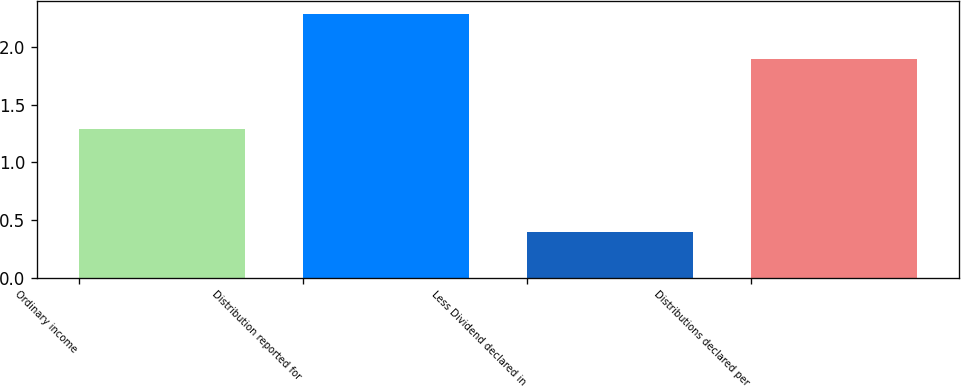Convert chart. <chart><loc_0><loc_0><loc_500><loc_500><bar_chart><fcel>Ordinary income<fcel>Distribution reported for<fcel>Less Dividend declared in<fcel>Distributions declared per<nl><fcel>1.29<fcel>2.29<fcel>0.4<fcel>1.9<nl></chart> 